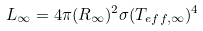<formula> <loc_0><loc_0><loc_500><loc_500>L _ { \infty } = 4 \pi ( R _ { \infty } ) ^ { 2 } \sigma ( T _ { e f f , \infty } ) ^ { 4 }</formula> 